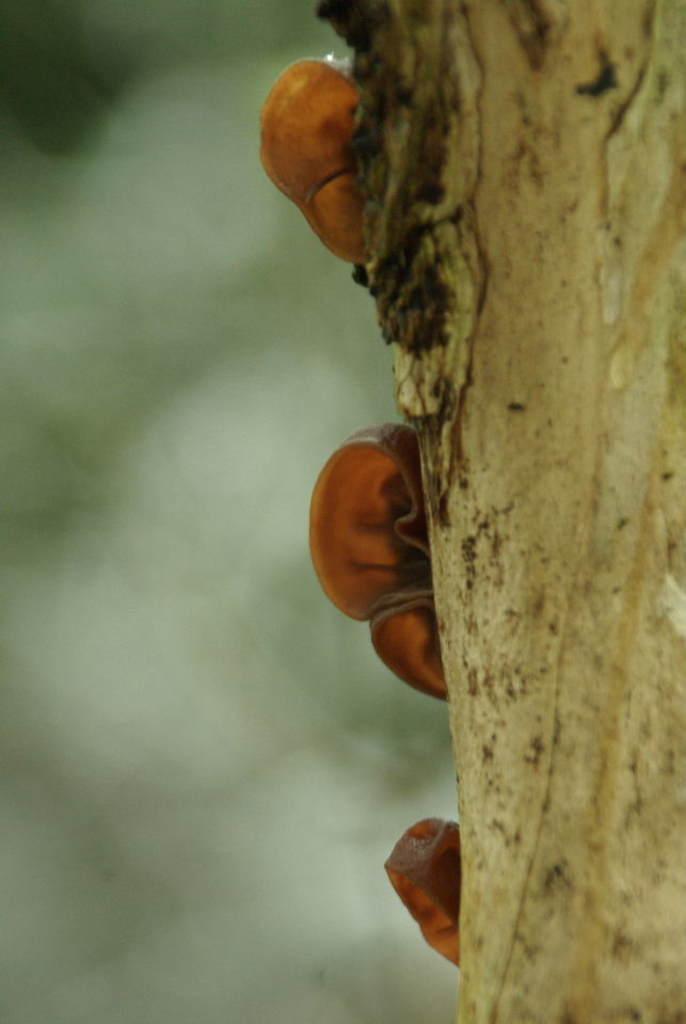In one or two sentences, can you explain what this image depicts? In this image there are insects on the bark of a tree. 